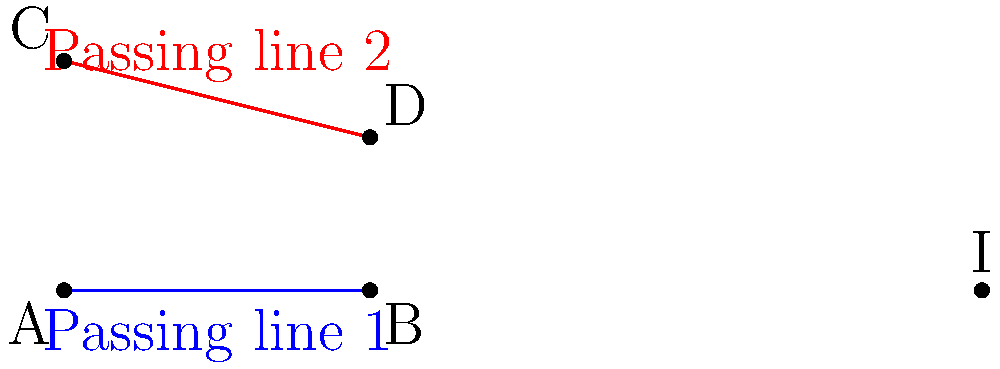In a basketball game, two passing lines are represented by the equations $y = 0$ and $y = -\frac{1}{4}x + 6$. Find the coordinates of the intersection point I, which represents the optimal spot for receiving a pass. To find the intersection point of the two passing lines, we need to solve the system of equations:

1) Line 1: $y = 0$
2) Line 2: $y = -\frac{1}{4}x + 6$

Step 1: Substitute the equation of Line 1 into Line 2
$0 = -\frac{1}{4}x + 6$

Step 2: Solve for x
$\frac{1}{4}x = 6$
$x = 6 \cdot 4 = 24$

Step 3: Find y by substituting x into either equation (we'll use Line 1)
$y = 0$

Step 4: The intersection point I is (24, 0)

Therefore, the optimal spot for receiving a pass is at the point (24, 0) on the court.
Answer: (24, 0) 